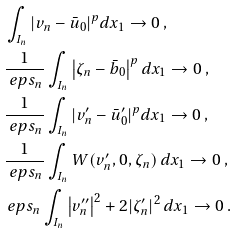Convert formula to latex. <formula><loc_0><loc_0><loc_500><loc_500>& \int _ { I _ { n } } | v _ { n } - \bar { u } _ { 0 } | ^ { p } d x _ { 1 } \to 0 \, , \\ & \frac { 1 } { \ e p s _ { n } } \int _ { I _ { n } } \left | \zeta _ { n } - \bar { b } _ { 0 } \right | ^ { p } d x _ { 1 } \to 0 \, , \\ & \frac { 1 } { \ e p s _ { n } } \int _ { I _ { n } } | v ^ { \prime } _ { n } - \bar { u } ^ { \prime } _ { 0 } | ^ { p } d x _ { 1 } \to 0 \, , \\ & \frac { 1 } { \ e p s _ { n } } \int _ { I _ { n } } W ( v ^ { \prime } _ { n } , 0 , \zeta _ { n } ) \, d x _ { 1 } \to 0 \, , \\ & \ e p s _ { n } \int _ { I _ { n } } \left | v ^ { \prime \prime } _ { n } \right | ^ { 2 } + 2 | \zeta ^ { \prime } _ { n } | ^ { 2 } \, d x _ { 1 } \to 0 \, .</formula> 